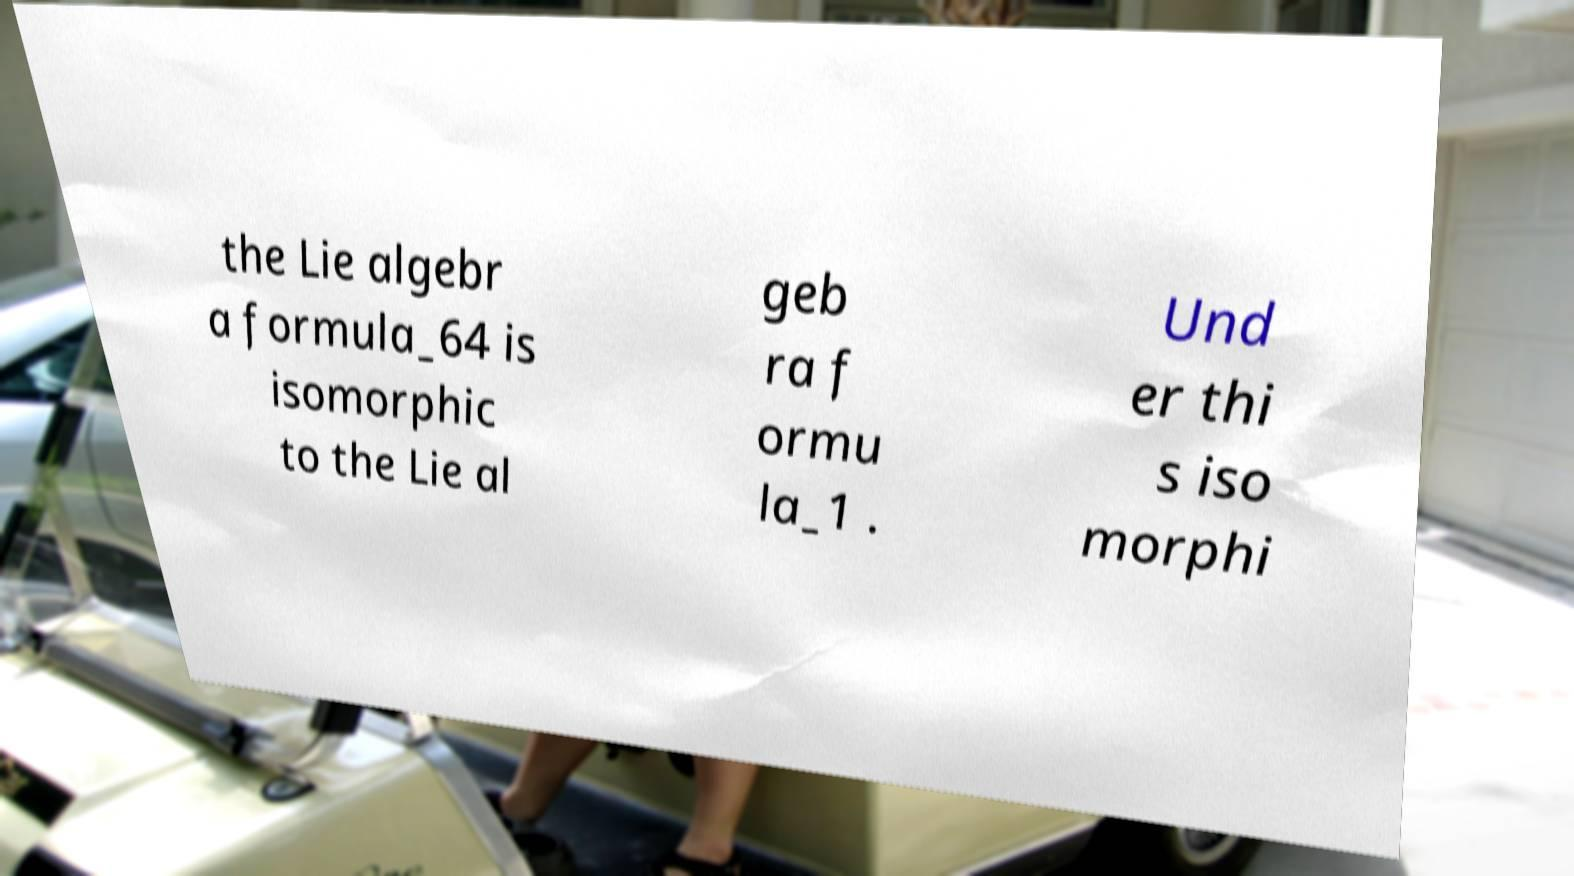There's text embedded in this image that I need extracted. Can you transcribe it verbatim? the Lie algebr a formula_64 is isomorphic to the Lie al geb ra f ormu la_1 . Und er thi s iso morphi 